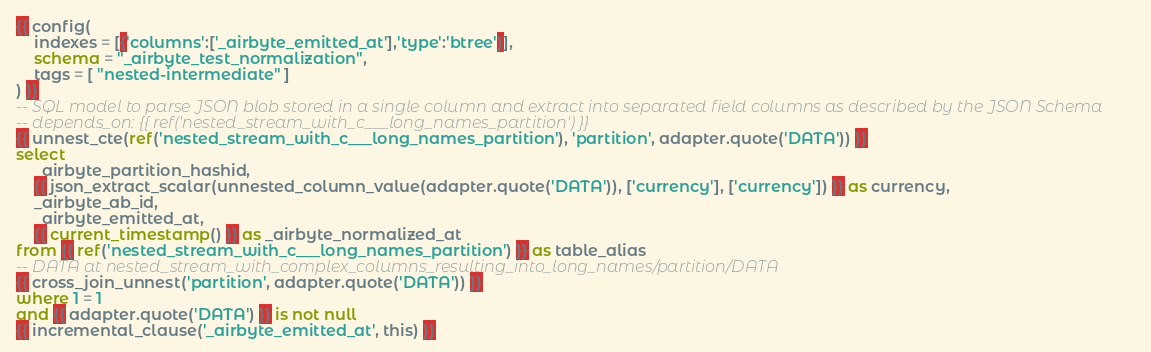Convert code to text. <code><loc_0><loc_0><loc_500><loc_500><_SQL_>{{ config(
    indexes = [{'columns':['_airbyte_emitted_at'],'type':'btree'}],
    schema = "_airbyte_test_normalization",
    tags = [ "nested-intermediate" ]
) }}
-- SQL model to parse JSON blob stored in a single column and extract into separated field columns as described by the JSON Schema
-- depends_on: {{ ref('nested_stream_with_c___long_names_partition') }}
{{ unnest_cte(ref('nested_stream_with_c___long_names_partition'), 'partition', adapter.quote('DATA')) }}
select
    _airbyte_partition_hashid,
    {{ json_extract_scalar(unnested_column_value(adapter.quote('DATA')), ['currency'], ['currency']) }} as currency,
    _airbyte_ab_id,
    _airbyte_emitted_at,
    {{ current_timestamp() }} as _airbyte_normalized_at
from {{ ref('nested_stream_with_c___long_names_partition') }} as table_alias
-- DATA at nested_stream_with_complex_columns_resulting_into_long_names/partition/DATA
{{ cross_join_unnest('partition', adapter.quote('DATA')) }}
where 1 = 1
and {{ adapter.quote('DATA') }} is not null
{{ incremental_clause('_airbyte_emitted_at', this) }}

</code> 